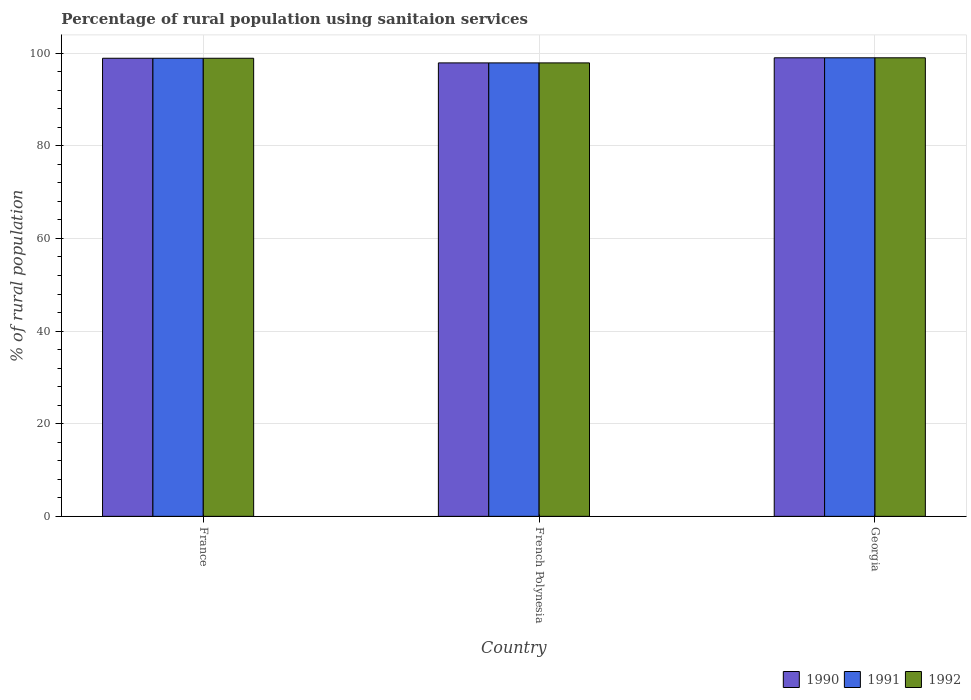How many groups of bars are there?
Give a very brief answer. 3. Are the number of bars on each tick of the X-axis equal?
Ensure brevity in your answer.  Yes. How many bars are there on the 1st tick from the left?
Give a very brief answer. 3. How many bars are there on the 3rd tick from the right?
Provide a succinct answer. 3. What is the label of the 1st group of bars from the left?
Provide a succinct answer. France. In how many cases, is the number of bars for a given country not equal to the number of legend labels?
Make the answer very short. 0. What is the percentage of rural population using sanitaion services in 1991 in French Polynesia?
Make the answer very short. 97.9. Across all countries, what is the maximum percentage of rural population using sanitaion services in 1992?
Ensure brevity in your answer.  99. Across all countries, what is the minimum percentage of rural population using sanitaion services in 1991?
Keep it short and to the point. 97.9. In which country was the percentage of rural population using sanitaion services in 1992 maximum?
Your response must be concise. Georgia. In which country was the percentage of rural population using sanitaion services in 1990 minimum?
Ensure brevity in your answer.  French Polynesia. What is the total percentage of rural population using sanitaion services in 1990 in the graph?
Make the answer very short. 295.8. What is the difference between the percentage of rural population using sanitaion services in 1992 in France and the percentage of rural population using sanitaion services in 1991 in French Polynesia?
Give a very brief answer. 1. What is the average percentage of rural population using sanitaion services in 1990 per country?
Offer a terse response. 98.6. What is the difference between the percentage of rural population using sanitaion services of/in 1991 and percentage of rural population using sanitaion services of/in 1992 in French Polynesia?
Give a very brief answer. 0. What is the ratio of the percentage of rural population using sanitaion services in 1992 in France to that in Georgia?
Your answer should be compact. 1. Is the percentage of rural population using sanitaion services in 1991 in France less than that in Georgia?
Give a very brief answer. Yes. Is the difference between the percentage of rural population using sanitaion services in 1991 in France and French Polynesia greater than the difference between the percentage of rural population using sanitaion services in 1992 in France and French Polynesia?
Provide a short and direct response. No. What is the difference between the highest and the second highest percentage of rural population using sanitaion services in 1992?
Provide a succinct answer. -1. What is the difference between the highest and the lowest percentage of rural population using sanitaion services in 1992?
Offer a terse response. 1.1. What does the 2nd bar from the left in France represents?
Ensure brevity in your answer.  1991. What does the 3rd bar from the right in France represents?
Provide a short and direct response. 1990. Is it the case that in every country, the sum of the percentage of rural population using sanitaion services in 1990 and percentage of rural population using sanitaion services in 1992 is greater than the percentage of rural population using sanitaion services in 1991?
Ensure brevity in your answer.  Yes. How many bars are there?
Your response must be concise. 9. How many countries are there in the graph?
Provide a succinct answer. 3. Does the graph contain any zero values?
Your response must be concise. No. Does the graph contain grids?
Provide a succinct answer. Yes. Where does the legend appear in the graph?
Make the answer very short. Bottom right. How are the legend labels stacked?
Ensure brevity in your answer.  Horizontal. What is the title of the graph?
Give a very brief answer. Percentage of rural population using sanitaion services. What is the label or title of the X-axis?
Keep it short and to the point. Country. What is the label or title of the Y-axis?
Provide a short and direct response. % of rural population. What is the % of rural population in 1990 in France?
Keep it short and to the point. 98.9. What is the % of rural population in 1991 in France?
Ensure brevity in your answer.  98.9. What is the % of rural population of 1992 in France?
Your answer should be very brief. 98.9. What is the % of rural population in 1990 in French Polynesia?
Offer a very short reply. 97.9. What is the % of rural population in 1991 in French Polynesia?
Your response must be concise. 97.9. What is the % of rural population in 1992 in French Polynesia?
Offer a terse response. 97.9. What is the % of rural population of 1990 in Georgia?
Provide a short and direct response. 99. What is the % of rural population in 1991 in Georgia?
Your response must be concise. 99. Across all countries, what is the maximum % of rural population of 1990?
Ensure brevity in your answer.  99. Across all countries, what is the minimum % of rural population of 1990?
Give a very brief answer. 97.9. Across all countries, what is the minimum % of rural population in 1991?
Offer a very short reply. 97.9. Across all countries, what is the minimum % of rural population of 1992?
Give a very brief answer. 97.9. What is the total % of rural population of 1990 in the graph?
Your answer should be very brief. 295.8. What is the total % of rural population in 1991 in the graph?
Provide a succinct answer. 295.8. What is the total % of rural population of 1992 in the graph?
Your answer should be compact. 295.8. What is the difference between the % of rural population in 1990 in France and that in French Polynesia?
Provide a short and direct response. 1. What is the difference between the % of rural population of 1991 in France and that in Georgia?
Keep it short and to the point. -0.1. What is the difference between the % of rural population of 1992 in France and that in Georgia?
Your answer should be compact. -0.1. What is the difference between the % of rural population in 1992 in French Polynesia and that in Georgia?
Provide a short and direct response. -1.1. What is the difference between the % of rural population in 1991 in France and the % of rural population in 1992 in French Polynesia?
Offer a very short reply. 1. What is the difference between the % of rural population of 1991 in France and the % of rural population of 1992 in Georgia?
Your response must be concise. -0.1. What is the difference between the % of rural population in 1990 in French Polynesia and the % of rural population in 1991 in Georgia?
Provide a succinct answer. -1.1. What is the difference between the % of rural population of 1990 in French Polynesia and the % of rural population of 1992 in Georgia?
Your answer should be compact. -1.1. What is the average % of rural population in 1990 per country?
Make the answer very short. 98.6. What is the average % of rural population of 1991 per country?
Your answer should be compact. 98.6. What is the average % of rural population of 1992 per country?
Your response must be concise. 98.6. What is the difference between the % of rural population of 1990 and % of rural population of 1991 in France?
Ensure brevity in your answer.  0. What is the difference between the % of rural population in 1990 and % of rural population in 1991 in French Polynesia?
Provide a succinct answer. 0. What is the difference between the % of rural population of 1991 and % of rural population of 1992 in French Polynesia?
Make the answer very short. 0. What is the difference between the % of rural population in 1990 and % of rural population in 1991 in Georgia?
Make the answer very short. 0. What is the difference between the % of rural population of 1990 and % of rural population of 1992 in Georgia?
Offer a very short reply. 0. What is the ratio of the % of rural population of 1990 in France to that in French Polynesia?
Provide a short and direct response. 1.01. What is the ratio of the % of rural population of 1991 in France to that in French Polynesia?
Provide a short and direct response. 1.01. What is the ratio of the % of rural population in 1992 in France to that in French Polynesia?
Keep it short and to the point. 1.01. What is the ratio of the % of rural population of 1991 in France to that in Georgia?
Your answer should be very brief. 1. What is the ratio of the % of rural population in 1990 in French Polynesia to that in Georgia?
Make the answer very short. 0.99. What is the ratio of the % of rural population in 1991 in French Polynesia to that in Georgia?
Provide a short and direct response. 0.99. What is the ratio of the % of rural population in 1992 in French Polynesia to that in Georgia?
Give a very brief answer. 0.99. What is the difference between the highest and the second highest % of rural population in 1992?
Make the answer very short. 0.1. What is the difference between the highest and the lowest % of rural population of 1990?
Your answer should be compact. 1.1. 